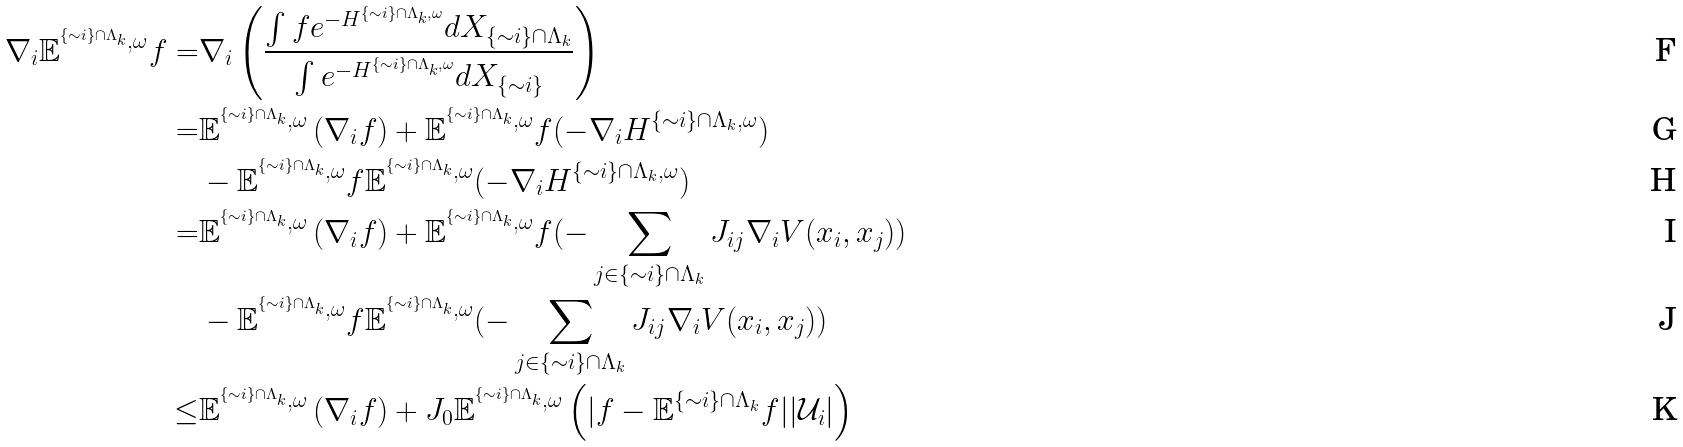Convert formula to latex. <formula><loc_0><loc_0><loc_500><loc_500>\nabla _ { i } \mathbb { E } ^ { ^ { \{ \sim i \} \cap \Lambda _ { k } } , \omega } f = & \nabla _ { i } \left ( \frac { \int f e ^ { - H ^ { \{ \sim i \} \cap \Lambda _ { k } , \omega } } d X _ { \{ \sim i \} \cap \Lambda _ { k } } } { \int e ^ { - H ^ { \{ \sim i \} \cap \Lambda _ { k } , \omega } } d X _ { \{ \sim i \} } } \right ) \\ = & \mathbb { E } ^ { ^ { \{ \sim i \} \cap \Lambda _ { k } } , \omega } \left ( \nabla _ { i } f \right ) + \mathbb { E } ^ { ^ { \{ \sim i \} \cap \Lambda _ { k } } , \omega } f ( - \nabla _ { i } H ^ { \{ \sim i \} \cap \Lambda _ { k } , \omega } ) \\ & - \mathbb { E } ^ { ^ { \{ \sim i \} \cap \Lambda _ { k } } , \omega } f \mathbb { E } ^ { ^ { \{ \sim i \} \cap \Lambda _ { k } } , \omega } ( - \nabla _ { i } H ^ { \{ \sim i \} \cap \Lambda _ { k } , \omega } ) \\ = & \mathbb { E } ^ { ^ { \{ \sim i \} \cap \Lambda _ { k } } , \omega } \left ( \nabla _ { i } f \right ) + \mathbb { E } ^ { ^ { \{ \sim i \} \cap \Lambda _ { k } } , \omega } f ( - \sum _ { j \in \{ \sim i \} \cap \Lambda _ { k } } J _ { i j } \nabla _ { i } V ( x _ { i } , x _ { j } ) ) \\ & - \mathbb { E } ^ { ^ { \{ \sim i \} \cap \Lambda _ { k } } , \omega } f \mathbb { E } ^ { ^ { \{ \sim i \} \cap \Lambda _ { k } } , \omega } ( - \sum _ { j \in \{ \sim i \} \cap \Lambda _ { k } } J _ { i j } \nabla _ { i } V ( x _ { i } , x _ { j } ) ) \\ \leq & \mathbb { E } ^ { ^ { \{ \sim i \} \cap \Lambda _ { k } } , \omega } \left ( \nabla _ { i } f \right ) + J _ { 0 } \mathbb { E } ^ { ^ { \{ \sim i \} \cap \Lambda _ { k } } , \omega } \left ( | f - \mathbb { E } ^ { \{ \sim i \} \cap \Lambda _ { k } } f | | \mathcal { U } _ { i } | \right )</formula> 